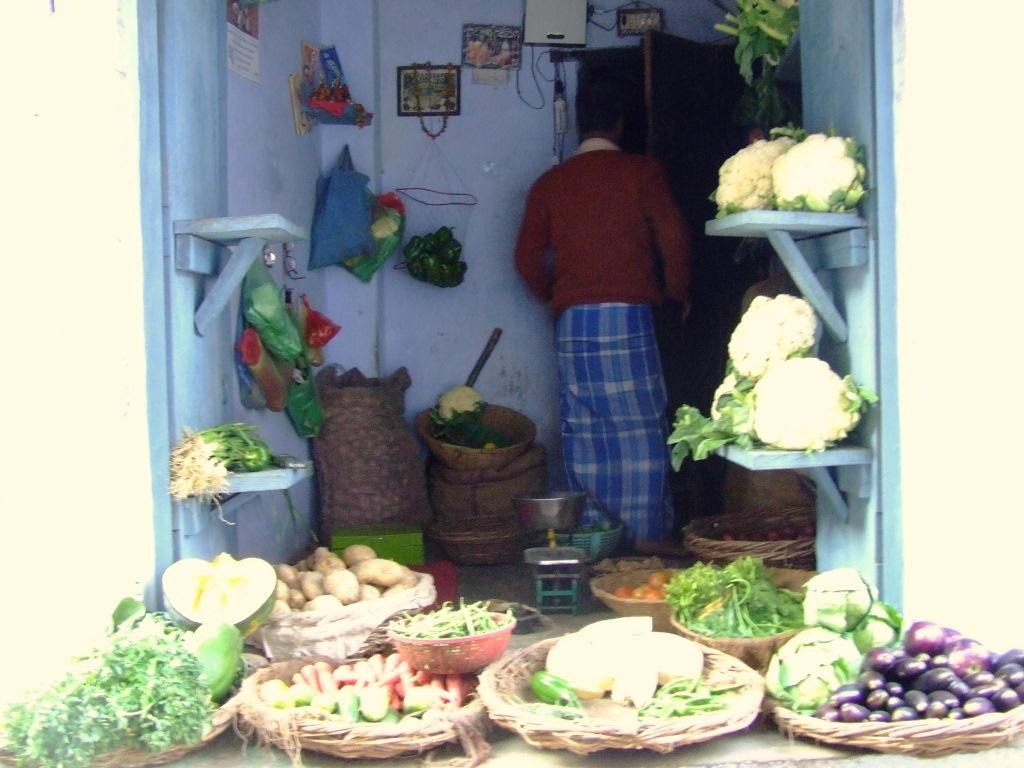What type of establishment is depicted in the image? The image is of a vegetable stall. What can be found on the vegetable stall? There are vegetables in baskets on the vegetable stall. Is there anyone present at the vegetable stall? Yes, there is a person standing at the vegetable stall. What can be seen on the wall in the image? There are photo frames on the wall in the image. What song is the person singing at the vegetable stall? There is no indication in the image that the person is singing a song, so it cannot be determined from the picture. 